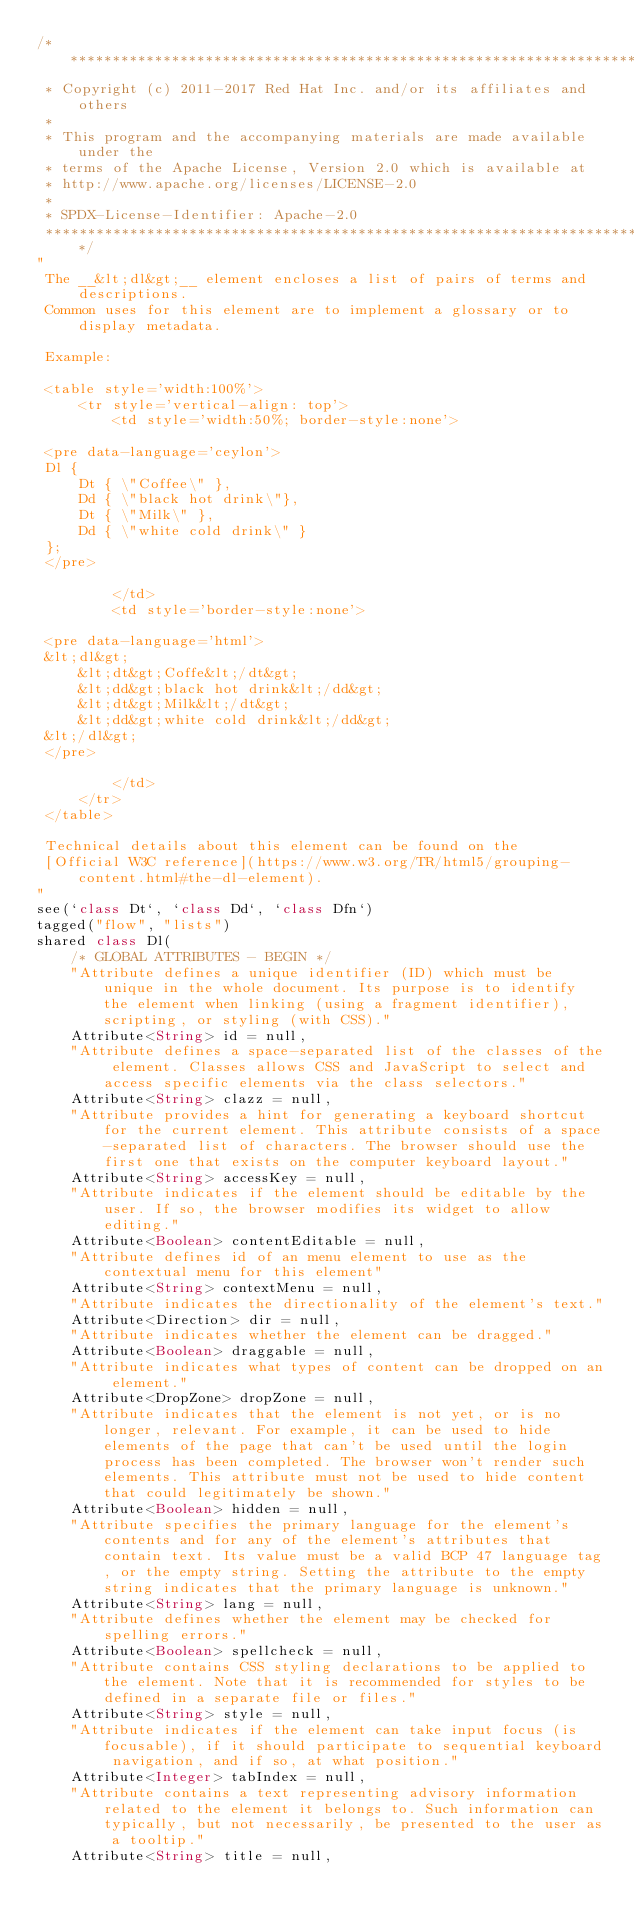Convert code to text. <code><loc_0><loc_0><loc_500><loc_500><_Ceylon_>/********************************************************************************
 * Copyright (c) 2011-2017 Red Hat Inc. and/or its affiliates and others
 *
 * This program and the accompanying materials are made available under the 
 * terms of the Apache License, Version 2.0 which is available at
 * http://www.apache.org/licenses/LICENSE-2.0
 *
 * SPDX-License-Identifier: Apache-2.0 
 ********************************************************************************/
"
 The __&lt;dl&gt;__ element encloses a list of pairs of terms and descriptions. 
 Common uses for this element are to implement a glossary or to display metadata.
 
 Example:
 
 <table style='width:100%'>
     <tr style='vertical-align: top'>
         <td style='width:50%; border-style:none'>
                  
 <pre data-language='ceylon'>
 Dl {
     Dt { \"Coffee\" },
     Dd { \"black hot drink\"},
     Dt { \"Milk\" },
     Dd { \"white cold drink\" }
 };
 </pre>
 
         </td>
         <td style='border-style:none'>
         
 <pre data-language='html'>
 &lt;dl&gt;
     &lt;dt&gt;Coffe&lt;/dt&gt;
     &lt;dd&gt;black hot drink&lt;/dd&gt;
     &lt;dt&gt;Milk&lt;/dt&gt;
     &lt;dd&gt;white cold drink&lt;/dd&gt;
 &lt;/dl&gt;
 </pre>
 
         </td>         
     </tr>
 </table>
 
 Technical details about this element can be found on the
 [Official W3C reference](https://www.w3.org/TR/html5/grouping-content.html#the-dl-element).
"
see(`class Dt`, `class Dd`, `class Dfn`)
tagged("flow", "lists")
shared class Dl(
    /* GLOBAL ATTRIBUTES - BEGIN */
    "Attribute defines a unique identifier (ID) which must be unique in the whole document. Its purpose is to identify the element when linking (using a fragment identifier), scripting, or styling (with CSS)."
    Attribute<String> id = null,
    "Attribute defines a space-separated list of the classes of the element. Classes allows CSS and JavaScript to select and access specific elements via the class selectors."
    Attribute<String> clazz = null,
    "Attribute provides a hint for generating a keyboard shortcut for the current element. This attribute consists of a space-separated list of characters. The browser should use the first one that exists on the computer keyboard layout."
    Attribute<String> accessKey = null,
    "Attribute indicates if the element should be editable by the user. If so, the browser modifies its widget to allow editing."
    Attribute<Boolean> contentEditable = null,
    "Attribute defines id of an menu element to use as the contextual menu for this element"
    Attribute<String> contextMenu = null,
    "Attribute indicates the directionality of the element's text."
    Attribute<Direction> dir = null,
    "Attribute indicates whether the element can be dragged."
    Attribute<Boolean> draggable = null,
    "Attribute indicates what types of content can be dropped on an element."
    Attribute<DropZone> dropZone = null,
    "Attribute indicates that the element is not yet, or is no longer, relevant. For example, it can be used to hide elements of the page that can't be used until the login process has been completed. The browser won't render such elements. This attribute must not be used to hide content that could legitimately be shown."
    Attribute<Boolean> hidden = null,
    "Attribute specifies the primary language for the element's contents and for any of the element's attributes that contain text. Its value must be a valid BCP 47 language tag, or the empty string. Setting the attribute to the empty string indicates that the primary language is unknown."
    Attribute<String> lang = null,
    "Attribute defines whether the element may be checked for spelling errors."
    Attribute<Boolean> spellcheck = null,
    "Attribute contains CSS styling declarations to be applied to the element. Note that it is recommended for styles to be defined in a separate file or files."
    Attribute<String> style = null,
    "Attribute indicates if the element can take input focus (is focusable), if it should participate to sequential keyboard navigation, and if so, at what position."
    Attribute<Integer> tabIndex = null,
    "Attribute contains a text representing advisory information related to the element it belongs to. Such information can typically, but not necessarily, be presented to the user as a tooltip."
    Attribute<String> title = null,</code> 